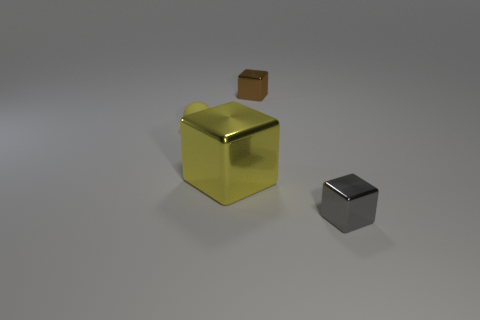There is a object that is the same color as the ball; what is its material?
Provide a succinct answer. Metal. Is there a small ball of the same color as the large object?
Provide a succinct answer. Yes. Is the color of the tiny object that is to the left of the large metallic thing the same as the big metallic thing?
Offer a very short reply. Yes. Is the number of big cubes greater than the number of large red cylinders?
Provide a short and direct response. Yes. There is a large cube; is its color the same as the tiny thing that is on the left side of the small brown object?
Keep it short and to the point. Yes. What color is the tiny thing that is in front of the tiny brown cube and behind the tiny gray shiny cube?
Your response must be concise. Yellow. How many other things are there of the same material as the tiny gray cube?
Keep it short and to the point. 2. Are there fewer tiny brown cubes than cyan shiny objects?
Make the answer very short. No. Do the yellow ball and the tiny object behind the tiny yellow thing have the same material?
Offer a very short reply. No. The small metal thing that is in front of the yellow metallic object has what shape?
Give a very brief answer. Cube. 